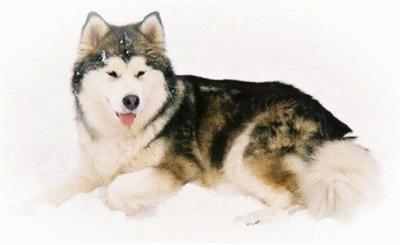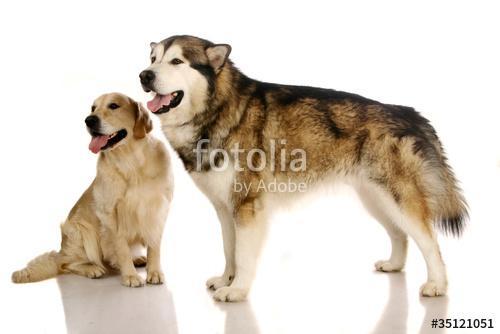The first image is the image on the left, the second image is the image on the right. Analyze the images presented: Is the assertion "In one image there is one dog, and in the other image there are two dogs that are the same breed." valid? Answer yes or no. No. The first image is the image on the left, the second image is the image on the right. Examine the images to the left and right. Is the description "The combined images include three husky dogs that are standing up and at least two dogs with their tongues hanging out of smiling mouths." accurate? Answer yes or no. No. 